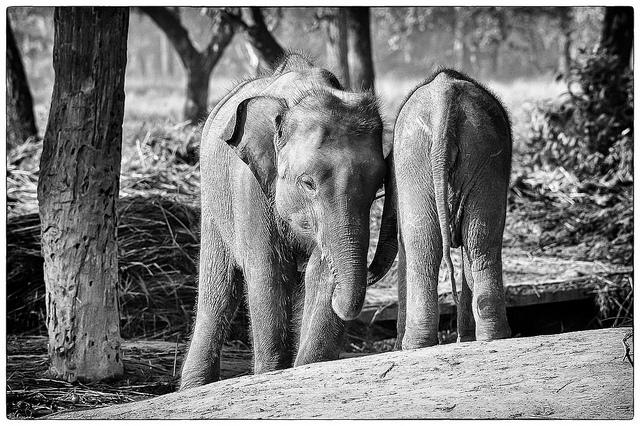Are the elephants facing each other?
Concise answer only. No. Do these animals look like they are in the zoo?
Keep it brief. No. Is it sunny or raining in this picture?
Write a very short answer. Sunny. 